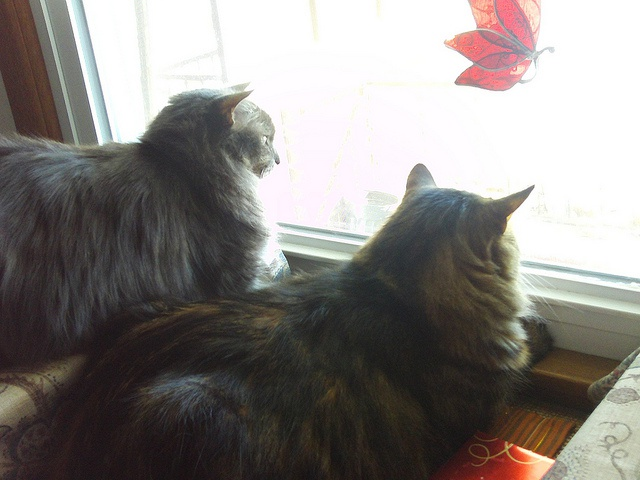Describe the objects in this image and their specific colors. I can see cat in maroon, black, and gray tones and cat in maroon, black, gray, darkgray, and white tones in this image. 